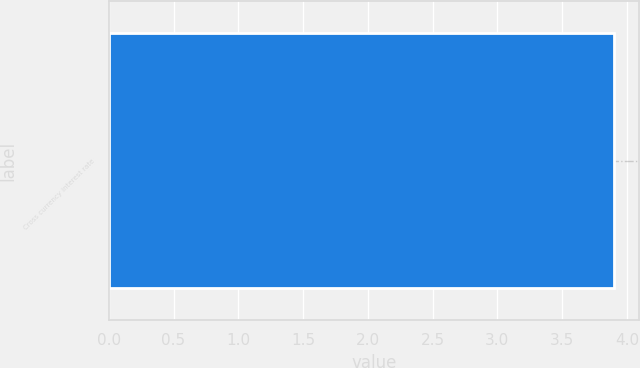Convert chart. <chart><loc_0><loc_0><loc_500><loc_500><bar_chart><fcel>Cross currency interest rate<nl><fcel>3.9<nl></chart> 